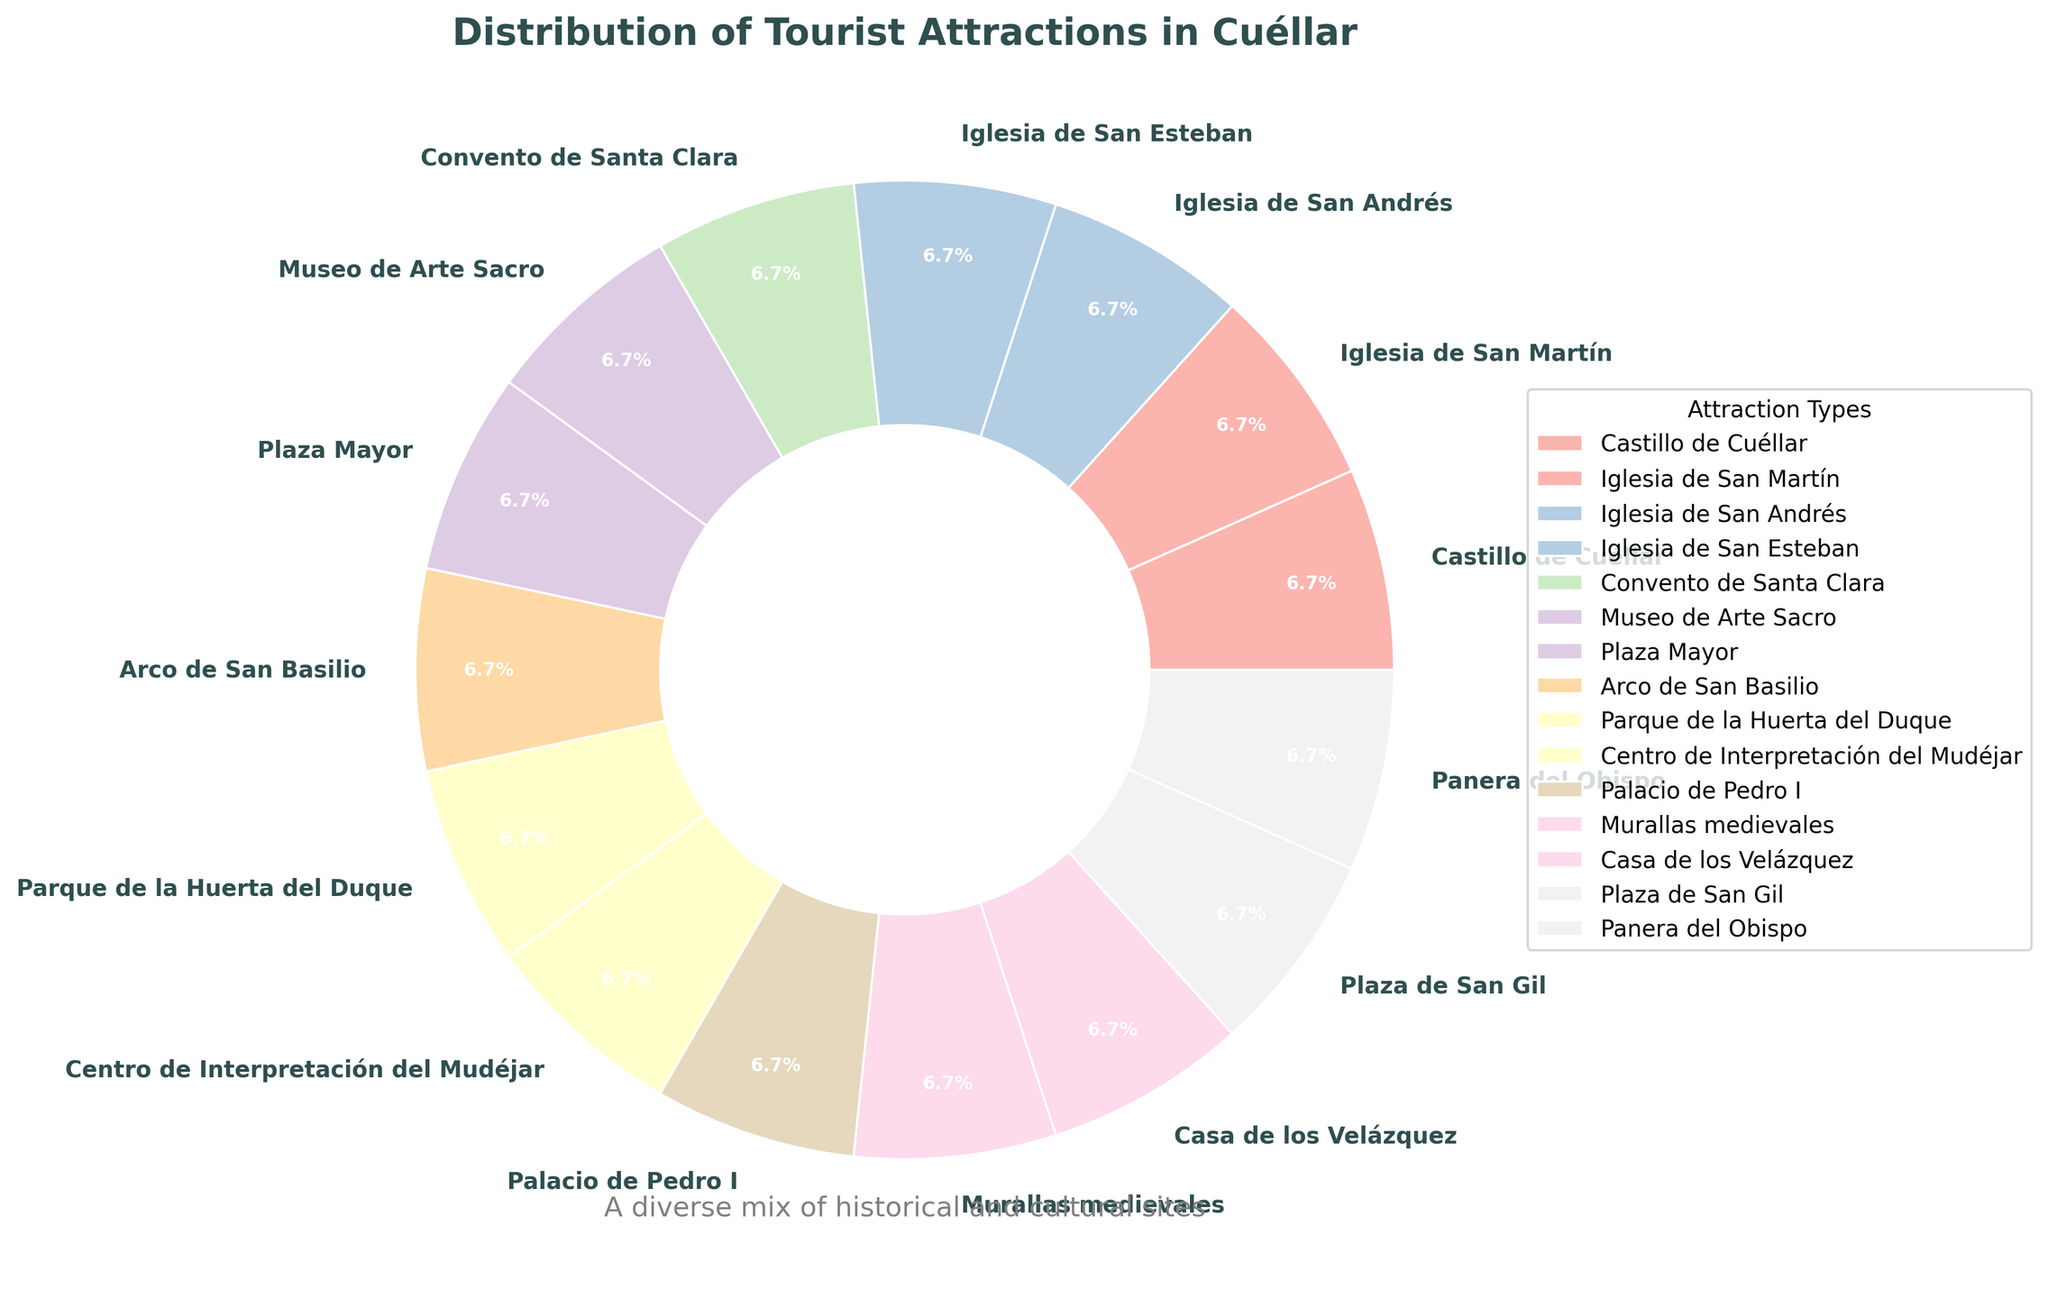What type of attraction makes up the greatest portion of tourist attractions in Cuéllar? Upon observing the figure, we see that all attraction types are displayed with labels and respective percentages. Since all attraction types each have 1 attraction, they all make up an equal percentage of the chart.
Answer: All types are equal Which two types of attractions are positioned adjacently in the pie chart? By examining the pie chart, we notice that adjacent sections represent adjacent types. For instance, Castillo de Cuéllar and the nearby Iglesia de San Martín are next to each other.
Answer: Castillo de Cuéllar and Iglesia de San Martín What percentage of tourist attractions are religious sites (churches and convents)? Identify the sections labeled Iglesia de San Martín, Iglesia de San Andrés, Iglesia de San Esteban, and Convento de Santa Clara. Each of these constitutes 1/15 of the total, equating to 4/15. Calculate the percentage (4/15 * 100).
Answer: 26.7% Are there more historical buildings or parks in Cuéllar based on the chart? Visualize the sections labeled as historical buildings (like Castillo de Cuéllar, Murallas medievales, etc.) compared to the section labeled as parks (Parque de la Huerta del Duque). There are more historical buildings.
Answer: Historical buildings Which attraction types have the same percentage distribution, and what are those percentages? Each section of the pie chart is equally divided, meaning every type has an identical percentage representation. Read the percentage label on any section to determine the percentage.
Answer: All types, 6.7% What is the cumulative percentage of attractions that are neither churches nor parks? Count the sections that are churches and parks, subtract this count from the total number of attractions, and convert this into a percentage of the total. (15 total attractions - 4 churches - 1 park = 10). Calculate the percentage (10/15 * 100).
Answer: 66.7% If you combine all the medieval structures, what percentage of the total attractions do they represent? Identify the medieval structures sections (e.g., Castillo de Cuéllar, Murallas medievales, Arco de San Basilio) each contributing 1 of 15. Sum the fractions and convert to a percentage (3/15 * 100).
Answer: 20% Which section of the pie chart is represented by the color primarily close to pink? Look at the sections and identify the one visually close to pink based on the color palette. This should be easy by observing the hues in the pastel range.
Answer: Iglesia de San Martín 